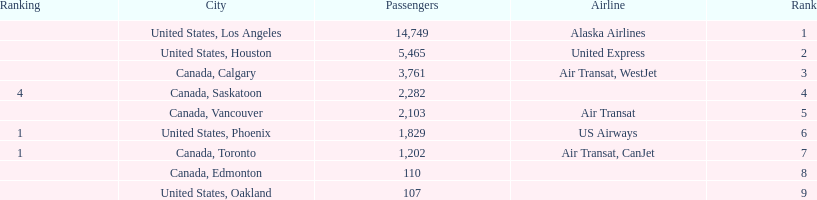Which canadian city had the most passengers traveling from manzanillo international airport in 2013? Calgary. Write the full table. {'header': ['Ranking', 'City', 'Passengers', 'Airline', 'Rank'], 'rows': [['', 'United States, Los Angeles', '14,749', 'Alaska Airlines', '1'], ['', 'United States, Houston', '5,465', 'United Express', '2'], ['', 'Canada, Calgary', '3,761', 'Air Transat, WestJet', '3'], ['4', 'Canada, Saskatoon', '2,282', '', '4'], ['', 'Canada, Vancouver', '2,103', 'Air Transat', '5'], ['1', 'United States, Phoenix', '1,829', 'US Airways', '6'], ['1', 'Canada, Toronto', '1,202', 'Air Transat, CanJet', '7'], ['', 'Canada, Edmonton', '110', '', '8'], ['', 'United States, Oakland', '107', '', '9']]} 